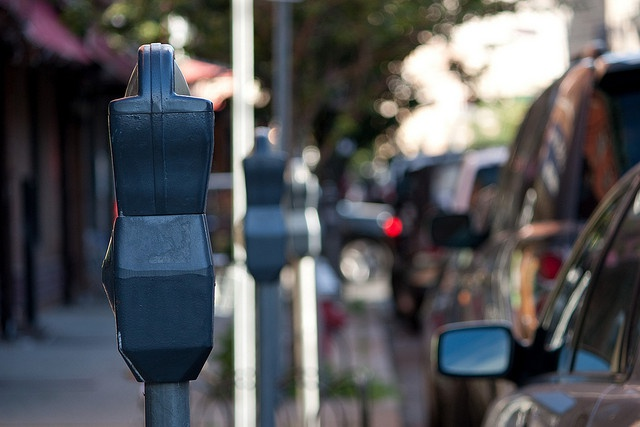Describe the objects in this image and their specific colors. I can see car in black, gray, and maroon tones, parking meter in black, navy, blue, and gray tones, car in black, gray, teal, and darkgray tones, parking meter in black, darkblue, blue, and gray tones, and car in black, gray, and darkgray tones in this image. 